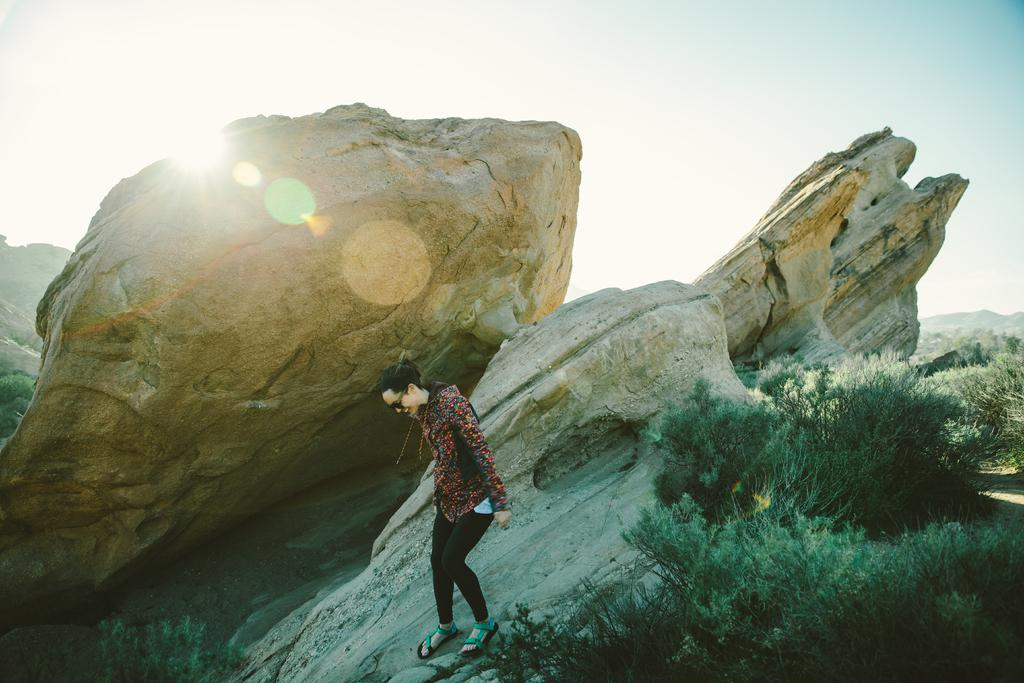What is the main subject of the image? There is a person in the image. What is the person wearing? The person is wearing a jacket and glasses. What is the person standing on? The person is standing on rocks. What can be seen in the background of the image? There are trees and the sky visible in the background of the image. What type of table can be seen in the image? There is no table present in the image. 